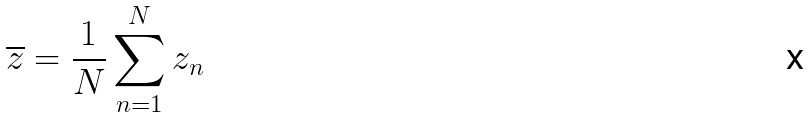<formula> <loc_0><loc_0><loc_500><loc_500>\overline { z } = \frac { 1 } { N } \sum _ { n = 1 } ^ { N } z _ { n }</formula> 